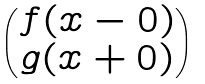<formula> <loc_0><loc_0><loc_500><loc_500>\begin{pmatrix} f ( x - 0 ) \\ g ( x + 0 ) \end{pmatrix}</formula> 